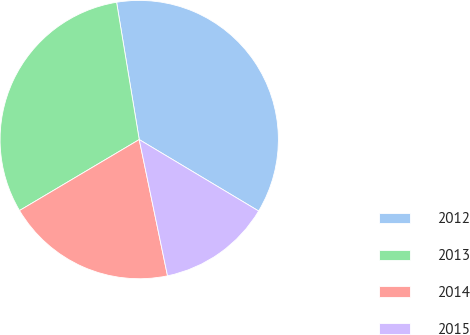<chart> <loc_0><loc_0><loc_500><loc_500><pie_chart><fcel>2012<fcel>2013<fcel>2014<fcel>2015<nl><fcel>36.18%<fcel>30.92%<fcel>19.74%<fcel>13.16%<nl></chart> 